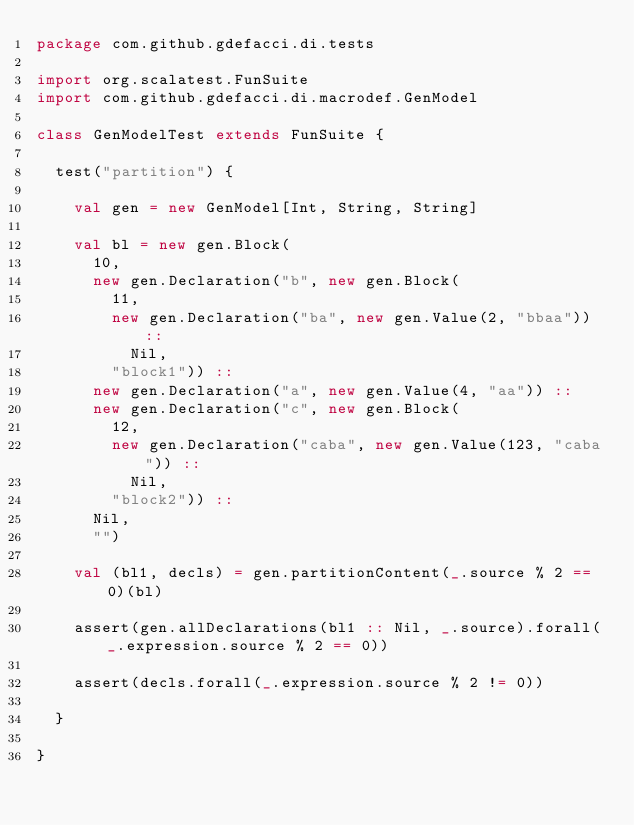Convert code to text. <code><loc_0><loc_0><loc_500><loc_500><_Scala_>package com.github.gdefacci.di.tests

import org.scalatest.FunSuite
import com.github.gdefacci.di.macrodef.GenModel

class GenModelTest extends FunSuite {

  test("partition") {

    val gen = new GenModel[Int, String, String]

    val bl = new gen.Block(
      10,
      new gen.Declaration("b", new gen.Block(
        11,
        new gen.Declaration("ba", new gen.Value(2, "bbaa")) ::
          Nil,
        "block1")) ::
      new gen.Declaration("a", new gen.Value(4, "aa")) ::
      new gen.Declaration("c", new gen.Block(
        12,
        new gen.Declaration("caba", new gen.Value(123, "caba")) ::
          Nil,
        "block2")) ::
      Nil,
      "")
    
    val (bl1, decls) = gen.partitionContent(_.source % 2 == 0)(bl)
    
    assert(gen.allDeclarations(bl1 :: Nil, _.source).forall(_.expression.source % 2 == 0))

    assert(decls.forall(_.expression.source % 2 != 0))

  }

}</code> 